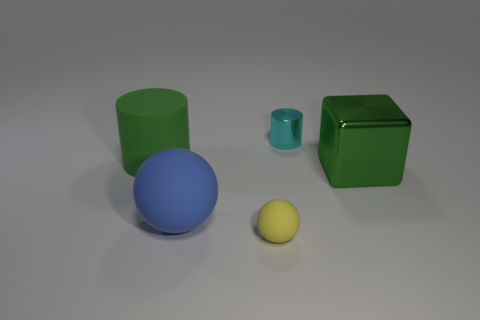What number of things are in front of the rubber cylinder? 3 